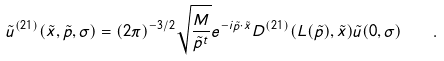<formula> <loc_0><loc_0><loc_500><loc_500>\tilde { u } ^ { ( 2 1 ) } ( \tilde { x } , \tilde { p } , \sigma ) = ( 2 \pi ) ^ { - 3 / 2 } \sqrt { \frac { M } { \tilde { p } ^ { t } } } e ^ { - i \tilde { p } \cdot \tilde { x } } D ^ { ( 2 1 ) } ( L ( \tilde { p } ) , \tilde { x } ) \tilde { u } ( 0 , \sigma ) \quad .</formula> 